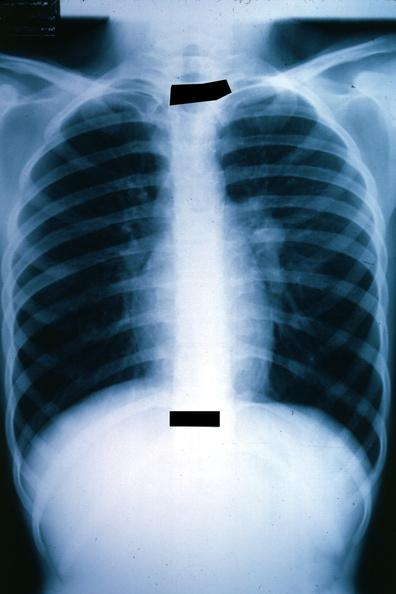how is x-ray chest shown left hilar tumor in hilar node?
Answer the question using a single word or phrase. Mass 